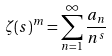Convert formula to latex. <formula><loc_0><loc_0><loc_500><loc_500>\zeta ( s ) ^ { m } = \sum _ { n = 1 } ^ { \infty } \frac { a _ { n } } { n ^ { s } }</formula> 